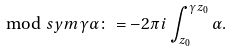Convert formula to latex. <formula><loc_0><loc_0><loc_500><loc_500>\mod s y m { \gamma } { \alpha } \colon = - 2 \pi i \int _ { z _ { 0 } } ^ { \gamma { z _ { 0 } } } \alpha .</formula> 